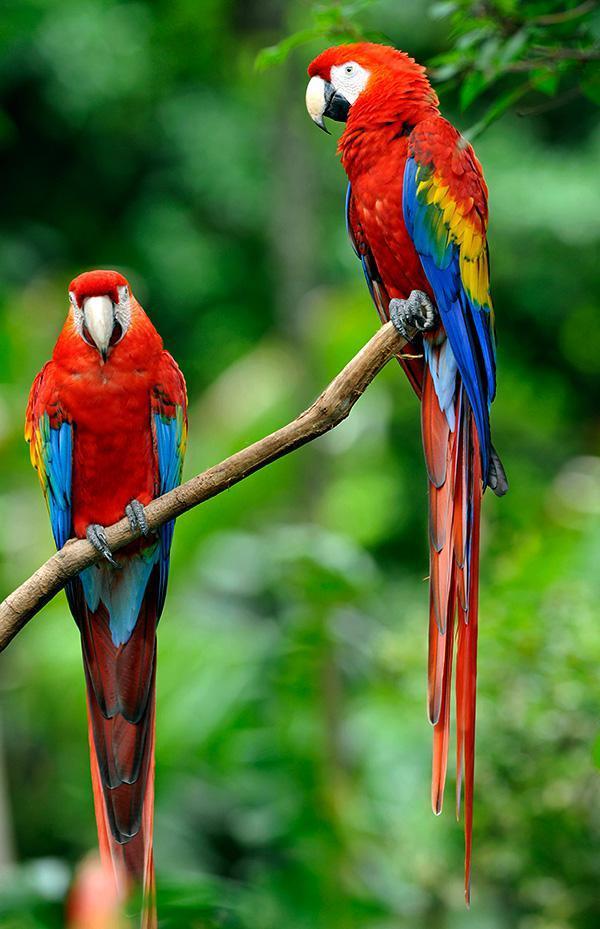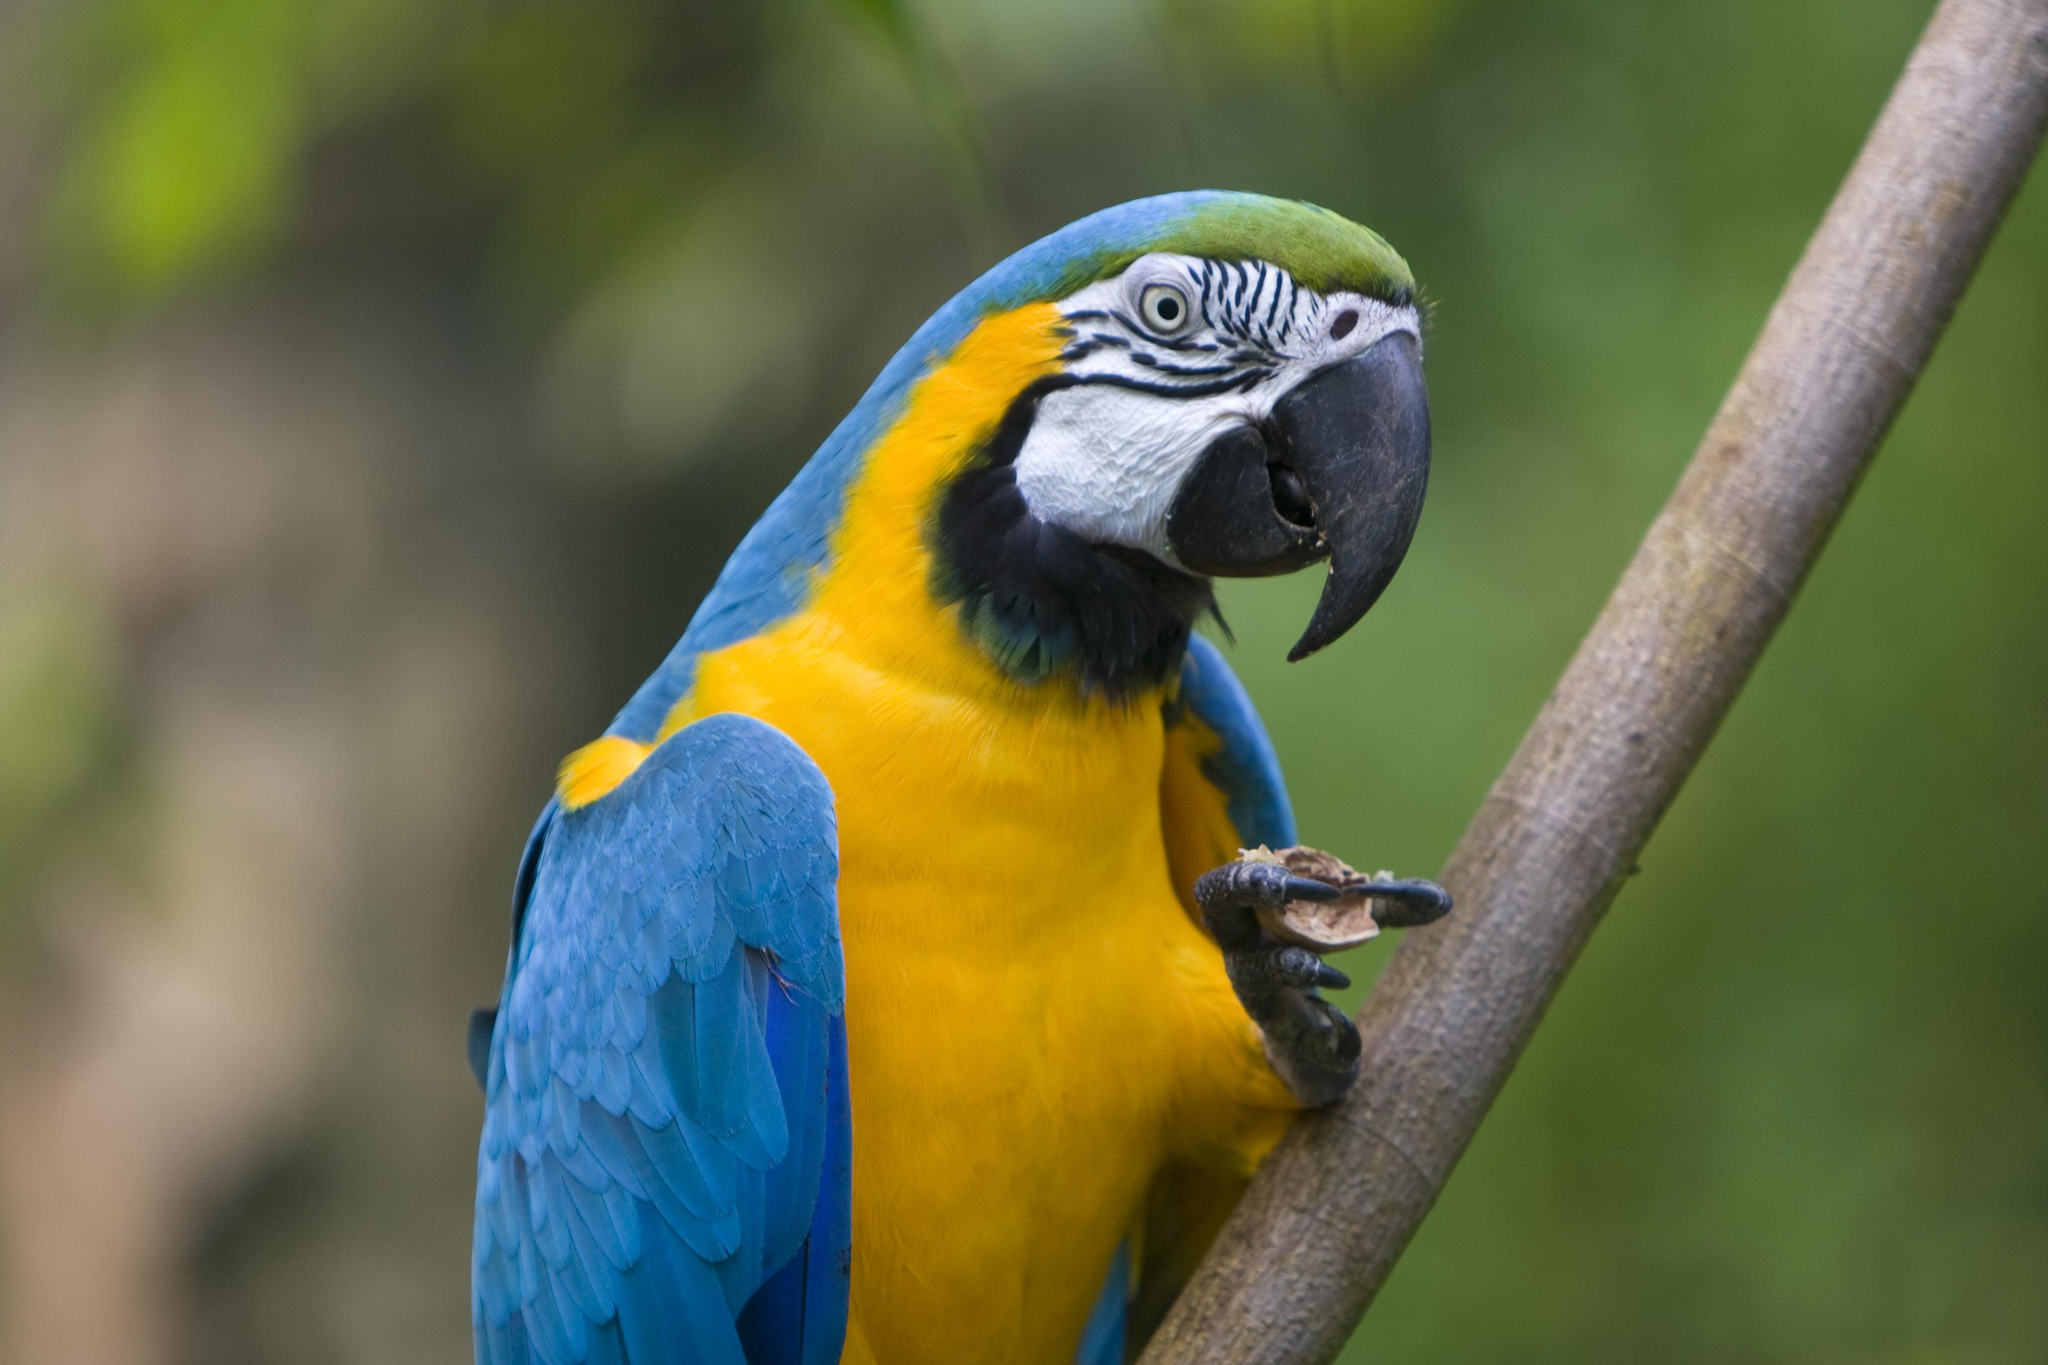The first image is the image on the left, the second image is the image on the right. Assess this claim about the two images: "There is exactly one parrot in the right image with a red head.". Correct or not? Answer yes or no. No. The first image is the image on the left, the second image is the image on the right. Examine the images to the left and right. Is the description "A total of three parrots are shown, and the left image contains two red-headed parrots." accurate? Answer yes or no. Yes. 